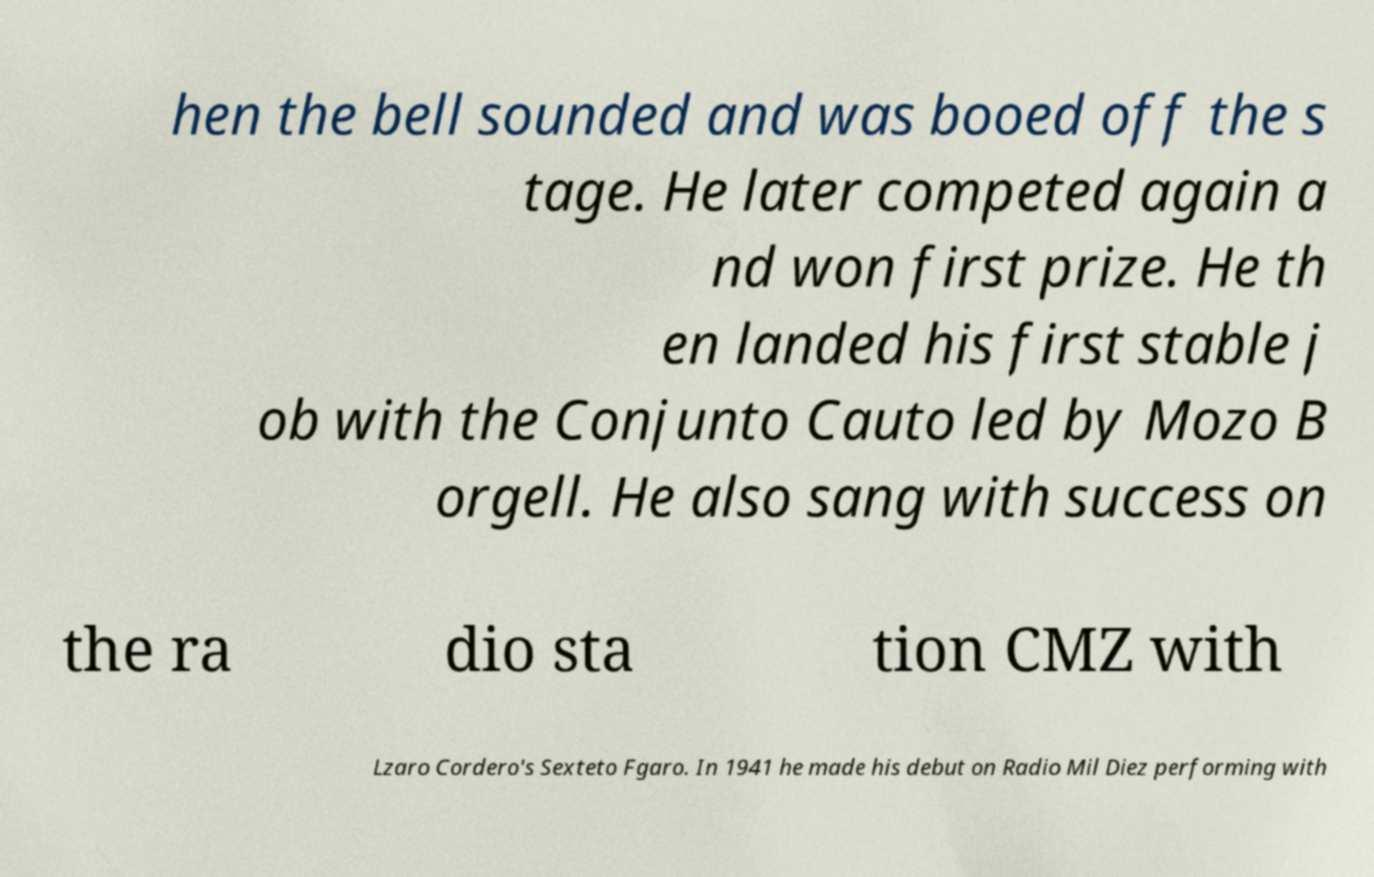Could you extract and type out the text from this image? hen the bell sounded and was booed off the s tage. He later competed again a nd won first prize. He th en landed his first stable j ob with the Conjunto Cauto led by Mozo B orgell. He also sang with success on the ra dio sta tion CMZ with Lzaro Cordero's Sexteto Fgaro. In 1941 he made his debut on Radio Mil Diez performing with 